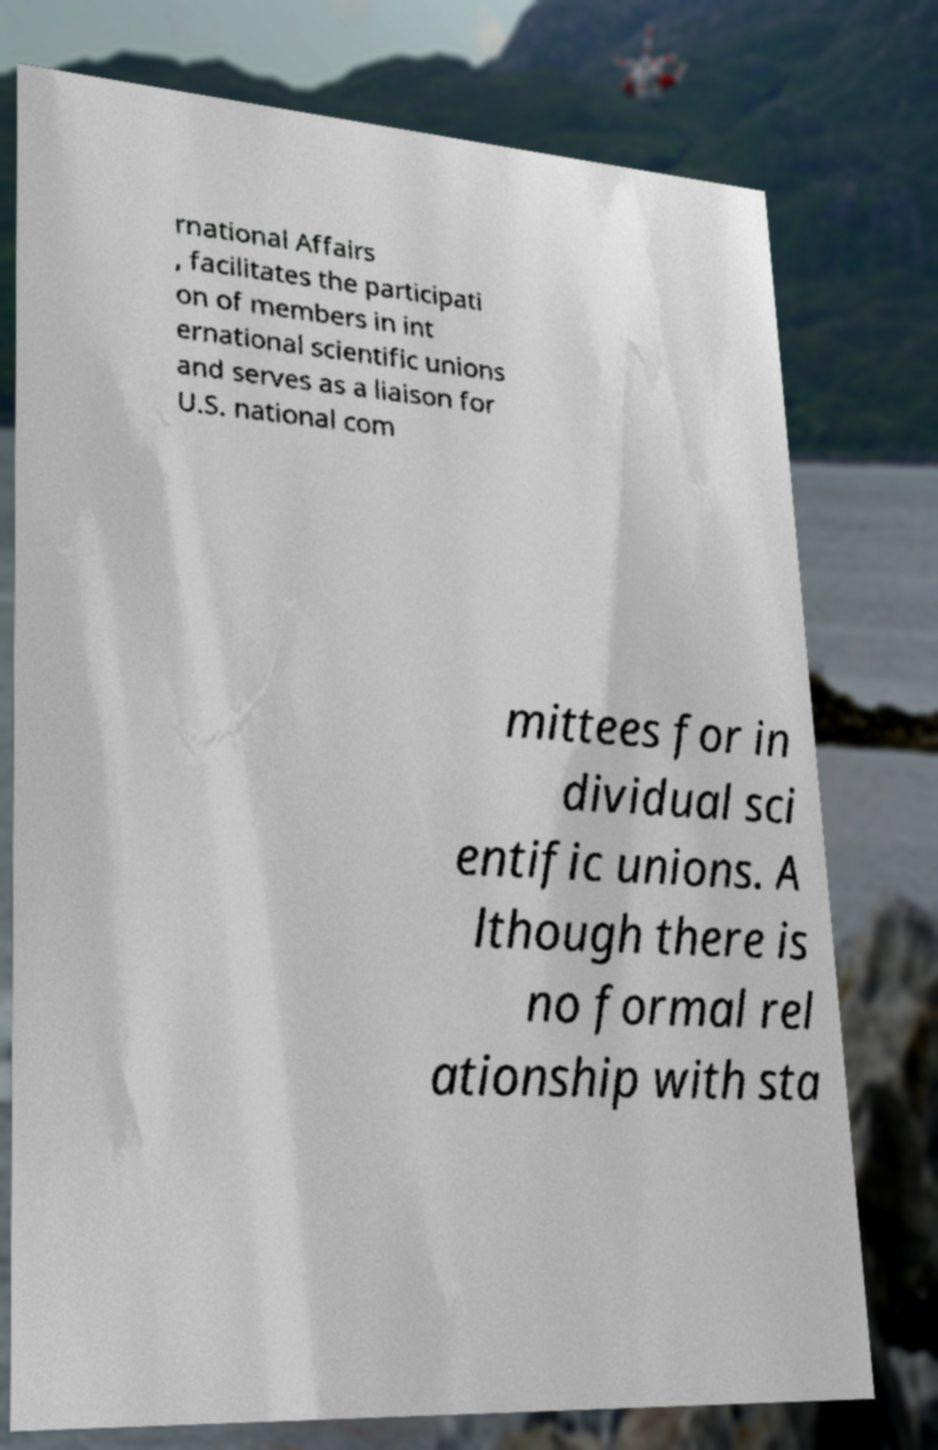Could you extract and type out the text from this image? rnational Affairs , facilitates the participati on of members in int ernational scientific unions and serves as a liaison for U.S. national com mittees for in dividual sci entific unions. A lthough there is no formal rel ationship with sta 